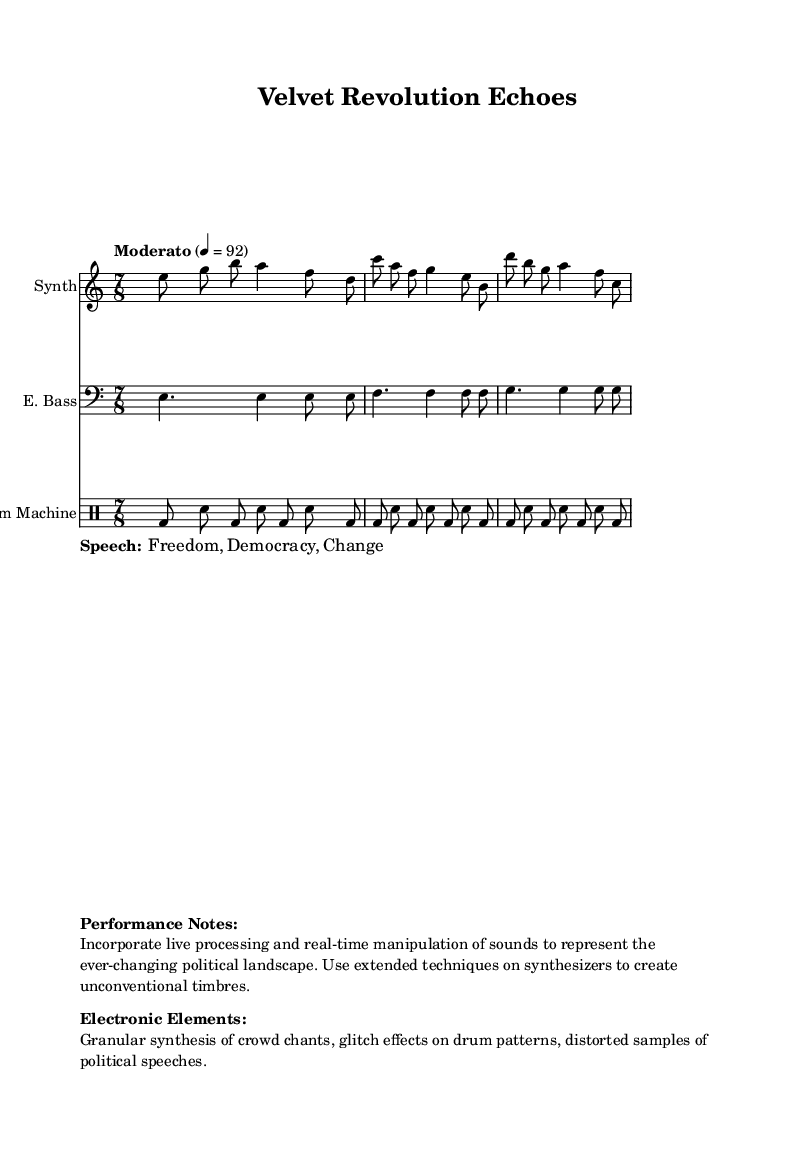What is the time signature of this composition? The time signature is indicated at the beginning of the piece and is 7/8, which means there are seven eighth notes in each measure.
Answer: 7/8 What is the tempo marking of the piece? The tempo marking, found at the beginning, indicates "Moderato" with a metronome marking of quarter note equals 92, suggesting a moderate pace.
Answer: Moderato, 4 = 92 What is the main instrument used in the synthesizer section? The synthesizer section is labeled with "Synth" in the score, indicating that the main instrument used is a synthesizer.
Answer: Synth How many measures are indicated in the drum machine part? While the sheet music shows the rhythmic patterns of the drum machine part, it is composed of three measures that follow the same pattern throughout.
Answer: 3 What type of musical techniques are specified in the performance notes? The performance notes indicate to incorporate live processing and real-time manipulation of sounds, as well as using extended techniques on synthesizers for unconventional timbres.
Answer: Live processing, extended techniques Which political movement inspires the composition? The title "Velvet Revolution Echoes" suggests that the composition is inspired by the Velvet Revolution, a significant political movement in Eastern Europe.
Answer: Velvet Revolution What electronic elements are mentioned in the performance notes? According to the description, the electronic elements include granular synthesis of crowd chants, glitch effects on drum patterns, and distorted samples of political speeches.
Answer: Granular synthesis, glitch effects, distorted samples 